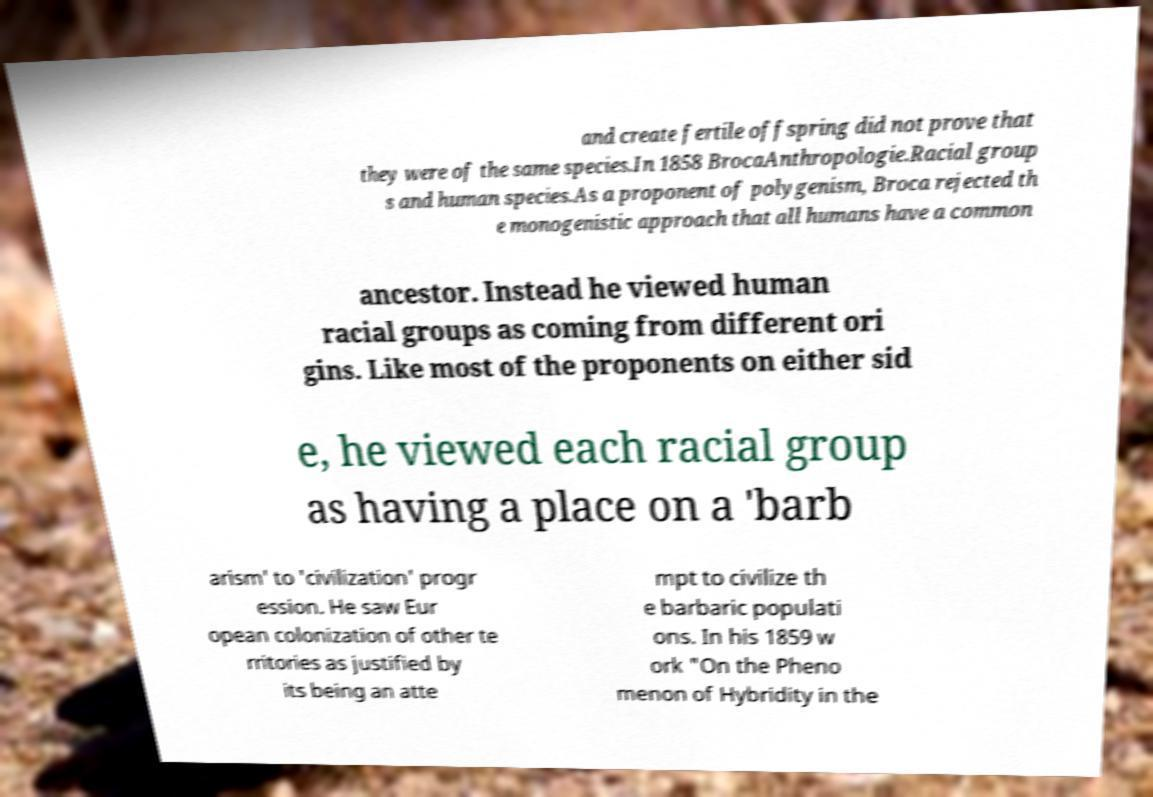There's text embedded in this image that I need extracted. Can you transcribe it verbatim? and create fertile offspring did not prove that they were of the same species.In 1858 BrocaAnthropologie.Racial group s and human species.As a proponent of polygenism, Broca rejected th e monogenistic approach that all humans have a common ancestor. Instead he viewed human racial groups as coming from different ori gins. Like most of the proponents on either sid e, he viewed each racial group as having a place on a 'barb arism' to 'civilization' progr ession. He saw Eur opean colonization of other te rritories as justified by its being an atte mpt to civilize th e barbaric populati ons. In his 1859 w ork "On the Pheno menon of Hybridity in the 